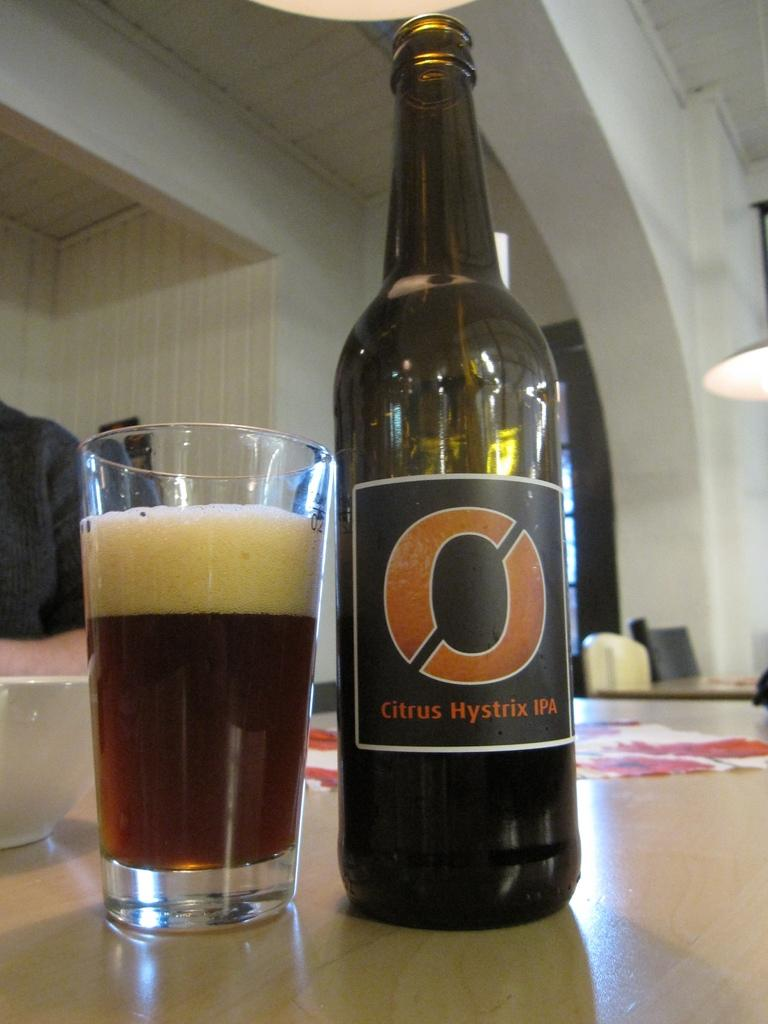<image>
Offer a succinct explanation of the picture presented. A bottle of O Citrus Hystric IPA next to an almost full glass. 